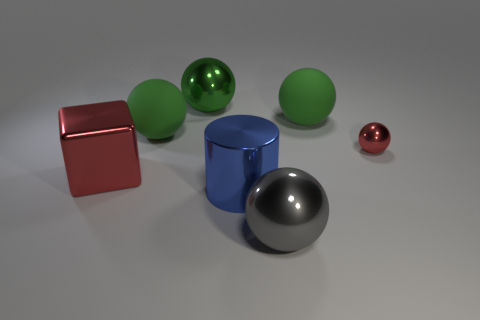How many green spheres must be subtracted to get 1 green spheres? 2 Subtract all blue blocks. How many green spheres are left? 3 Subtract all red spheres. How many spheres are left? 4 Subtract all gray balls. How many balls are left? 4 Subtract all cyan balls. Subtract all red cubes. How many balls are left? 5 Add 2 gray shiny things. How many objects exist? 9 Subtract all spheres. How many objects are left? 2 Subtract 0 gray cylinders. How many objects are left? 7 Subtract all large red metal cubes. Subtract all green rubber objects. How many objects are left? 4 Add 1 matte objects. How many matte objects are left? 3 